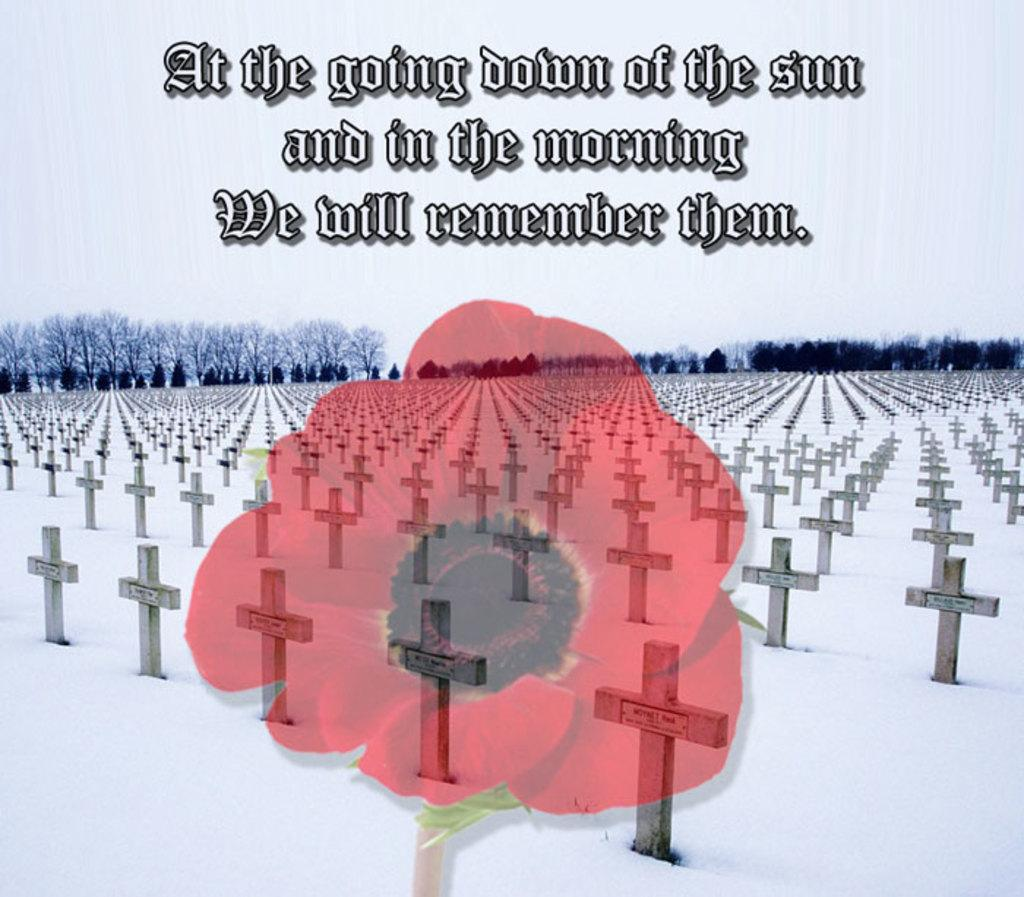What type of image is being described? The image is graphical in nature. What can be found in the image that is related to nature? There is a red color flower and trees in the image. What symbols are present in the image? There are crosses in the image. Is there any text in the image? Yes, there is a quotation in the image. How many planes are flying over the trees in the image? There are no planes present in the image; it only features a red color flower, trees, crosses, and a quotation. Who is the expert quoted in the image? There is no expert mentioned in the image; it only contains a quotation without attribution. 